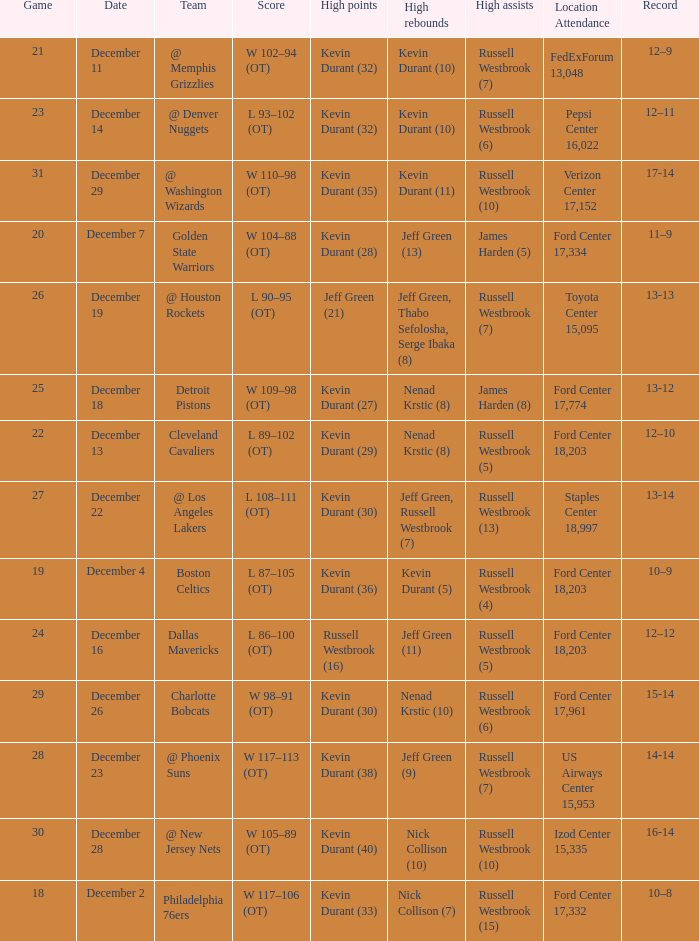Who has high points when toyota center 15,095 is location attendance? Jeff Green (21). 